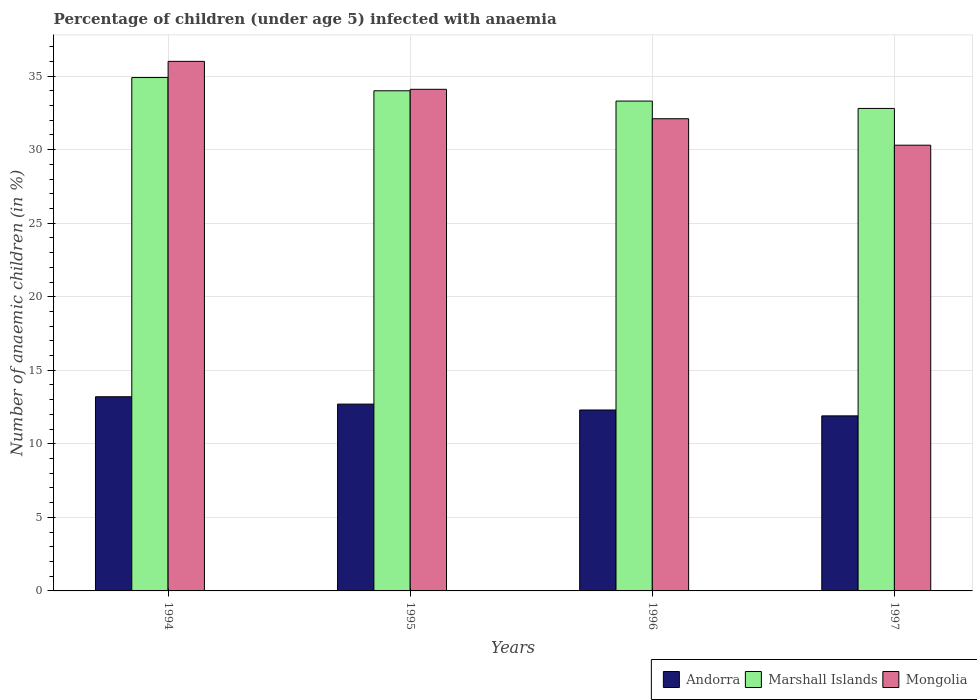How many groups of bars are there?
Provide a short and direct response. 4. Are the number of bars per tick equal to the number of legend labels?
Your answer should be compact. Yes. Are the number of bars on each tick of the X-axis equal?
Your response must be concise. Yes. What is the label of the 2nd group of bars from the left?
Your answer should be compact. 1995. Across all years, what is the maximum percentage of children infected with anaemia in in Andorra?
Give a very brief answer. 13.2. Across all years, what is the minimum percentage of children infected with anaemia in in Mongolia?
Make the answer very short. 30.3. In which year was the percentage of children infected with anaemia in in Marshall Islands maximum?
Provide a short and direct response. 1994. What is the total percentage of children infected with anaemia in in Andorra in the graph?
Keep it short and to the point. 50.1. What is the difference between the percentage of children infected with anaemia in in Marshall Islands in 1995 and that in 1996?
Provide a short and direct response. 0.7. What is the difference between the percentage of children infected with anaemia in in Andorra in 1997 and the percentage of children infected with anaemia in in Marshall Islands in 1994?
Keep it short and to the point. -23. What is the average percentage of children infected with anaemia in in Mongolia per year?
Provide a short and direct response. 33.12. In the year 1995, what is the difference between the percentage of children infected with anaemia in in Mongolia and percentage of children infected with anaemia in in Andorra?
Your response must be concise. 21.4. In how many years, is the percentage of children infected with anaemia in in Mongolia greater than 5 %?
Offer a very short reply. 4. What is the ratio of the percentage of children infected with anaemia in in Marshall Islands in 1995 to that in 1996?
Your response must be concise. 1.02. Is the percentage of children infected with anaemia in in Marshall Islands in 1995 less than that in 1996?
Keep it short and to the point. No. Is the difference between the percentage of children infected with anaemia in in Mongolia in 1994 and 1995 greater than the difference between the percentage of children infected with anaemia in in Andorra in 1994 and 1995?
Give a very brief answer. Yes. What is the difference between the highest and the second highest percentage of children infected with anaemia in in Mongolia?
Your answer should be compact. 1.9. What is the difference between the highest and the lowest percentage of children infected with anaemia in in Mongolia?
Provide a succinct answer. 5.7. In how many years, is the percentage of children infected with anaemia in in Mongolia greater than the average percentage of children infected with anaemia in in Mongolia taken over all years?
Offer a terse response. 2. Is the sum of the percentage of children infected with anaemia in in Andorra in 1994 and 1997 greater than the maximum percentage of children infected with anaemia in in Mongolia across all years?
Offer a very short reply. No. What does the 1st bar from the left in 1995 represents?
Give a very brief answer. Andorra. What does the 2nd bar from the right in 1996 represents?
Provide a short and direct response. Marshall Islands. Are all the bars in the graph horizontal?
Your response must be concise. No. What is the difference between two consecutive major ticks on the Y-axis?
Your answer should be very brief. 5. Does the graph contain any zero values?
Your response must be concise. No. Where does the legend appear in the graph?
Keep it short and to the point. Bottom right. How many legend labels are there?
Your response must be concise. 3. How are the legend labels stacked?
Your response must be concise. Horizontal. What is the title of the graph?
Ensure brevity in your answer.  Percentage of children (under age 5) infected with anaemia. What is the label or title of the X-axis?
Your response must be concise. Years. What is the label or title of the Y-axis?
Your answer should be compact. Number of anaemic children (in %). What is the Number of anaemic children (in %) in Andorra in 1994?
Keep it short and to the point. 13.2. What is the Number of anaemic children (in %) of Marshall Islands in 1994?
Make the answer very short. 34.9. What is the Number of anaemic children (in %) in Mongolia in 1995?
Keep it short and to the point. 34.1. What is the Number of anaemic children (in %) in Marshall Islands in 1996?
Offer a very short reply. 33.3. What is the Number of anaemic children (in %) of Mongolia in 1996?
Provide a succinct answer. 32.1. What is the Number of anaemic children (in %) of Marshall Islands in 1997?
Offer a terse response. 32.8. What is the Number of anaemic children (in %) of Mongolia in 1997?
Ensure brevity in your answer.  30.3. Across all years, what is the maximum Number of anaemic children (in %) of Andorra?
Give a very brief answer. 13.2. Across all years, what is the maximum Number of anaemic children (in %) in Marshall Islands?
Your answer should be very brief. 34.9. Across all years, what is the maximum Number of anaemic children (in %) in Mongolia?
Keep it short and to the point. 36. Across all years, what is the minimum Number of anaemic children (in %) of Andorra?
Keep it short and to the point. 11.9. Across all years, what is the minimum Number of anaemic children (in %) of Marshall Islands?
Provide a succinct answer. 32.8. Across all years, what is the minimum Number of anaemic children (in %) in Mongolia?
Make the answer very short. 30.3. What is the total Number of anaemic children (in %) of Andorra in the graph?
Make the answer very short. 50.1. What is the total Number of anaemic children (in %) of Marshall Islands in the graph?
Provide a succinct answer. 135. What is the total Number of anaemic children (in %) in Mongolia in the graph?
Offer a terse response. 132.5. What is the difference between the Number of anaemic children (in %) of Mongolia in 1994 and that in 1995?
Keep it short and to the point. 1.9. What is the difference between the Number of anaemic children (in %) in Andorra in 1994 and that in 1996?
Provide a succinct answer. 0.9. What is the difference between the Number of anaemic children (in %) in Mongolia in 1994 and that in 1996?
Your answer should be very brief. 3.9. What is the difference between the Number of anaemic children (in %) in Andorra in 1994 and that in 1997?
Offer a terse response. 1.3. What is the difference between the Number of anaemic children (in %) of Marshall Islands in 1994 and that in 1997?
Provide a succinct answer. 2.1. What is the difference between the Number of anaemic children (in %) in Mongolia in 1994 and that in 1997?
Ensure brevity in your answer.  5.7. What is the difference between the Number of anaemic children (in %) in Andorra in 1995 and that in 1996?
Offer a very short reply. 0.4. What is the difference between the Number of anaemic children (in %) of Andorra in 1995 and that in 1997?
Provide a short and direct response. 0.8. What is the difference between the Number of anaemic children (in %) in Marshall Islands in 1995 and that in 1997?
Provide a succinct answer. 1.2. What is the difference between the Number of anaemic children (in %) in Andorra in 1994 and the Number of anaemic children (in %) in Marshall Islands in 1995?
Your answer should be very brief. -20.8. What is the difference between the Number of anaemic children (in %) of Andorra in 1994 and the Number of anaemic children (in %) of Mongolia in 1995?
Offer a very short reply. -20.9. What is the difference between the Number of anaemic children (in %) in Andorra in 1994 and the Number of anaemic children (in %) in Marshall Islands in 1996?
Provide a short and direct response. -20.1. What is the difference between the Number of anaemic children (in %) of Andorra in 1994 and the Number of anaemic children (in %) of Mongolia in 1996?
Offer a very short reply. -18.9. What is the difference between the Number of anaemic children (in %) of Marshall Islands in 1994 and the Number of anaemic children (in %) of Mongolia in 1996?
Offer a very short reply. 2.8. What is the difference between the Number of anaemic children (in %) of Andorra in 1994 and the Number of anaemic children (in %) of Marshall Islands in 1997?
Offer a terse response. -19.6. What is the difference between the Number of anaemic children (in %) of Andorra in 1994 and the Number of anaemic children (in %) of Mongolia in 1997?
Provide a succinct answer. -17.1. What is the difference between the Number of anaemic children (in %) in Andorra in 1995 and the Number of anaemic children (in %) in Marshall Islands in 1996?
Provide a succinct answer. -20.6. What is the difference between the Number of anaemic children (in %) of Andorra in 1995 and the Number of anaemic children (in %) of Mongolia in 1996?
Keep it short and to the point. -19.4. What is the difference between the Number of anaemic children (in %) in Andorra in 1995 and the Number of anaemic children (in %) in Marshall Islands in 1997?
Ensure brevity in your answer.  -20.1. What is the difference between the Number of anaemic children (in %) of Andorra in 1995 and the Number of anaemic children (in %) of Mongolia in 1997?
Provide a succinct answer. -17.6. What is the difference between the Number of anaemic children (in %) of Andorra in 1996 and the Number of anaemic children (in %) of Marshall Islands in 1997?
Your answer should be very brief. -20.5. What is the difference between the Number of anaemic children (in %) of Andorra in 1996 and the Number of anaemic children (in %) of Mongolia in 1997?
Provide a short and direct response. -18. What is the average Number of anaemic children (in %) in Andorra per year?
Your response must be concise. 12.53. What is the average Number of anaemic children (in %) in Marshall Islands per year?
Your answer should be very brief. 33.75. What is the average Number of anaemic children (in %) in Mongolia per year?
Provide a short and direct response. 33.12. In the year 1994, what is the difference between the Number of anaemic children (in %) of Andorra and Number of anaemic children (in %) of Marshall Islands?
Provide a short and direct response. -21.7. In the year 1994, what is the difference between the Number of anaemic children (in %) in Andorra and Number of anaemic children (in %) in Mongolia?
Offer a very short reply. -22.8. In the year 1995, what is the difference between the Number of anaemic children (in %) in Andorra and Number of anaemic children (in %) in Marshall Islands?
Your answer should be compact. -21.3. In the year 1995, what is the difference between the Number of anaemic children (in %) of Andorra and Number of anaemic children (in %) of Mongolia?
Provide a succinct answer. -21.4. In the year 1996, what is the difference between the Number of anaemic children (in %) in Andorra and Number of anaemic children (in %) in Mongolia?
Offer a very short reply. -19.8. In the year 1997, what is the difference between the Number of anaemic children (in %) in Andorra and Number of anaemic children (in %) in Marshall Islands?
Provide a succinct answer. -20.9. In the year 1997, what is the difference between the Number of anaemic children (in %) of Andorra and Number of anaemic children (in %) of Mongolia?
Your answer should be very brief. -18.4. In the year 1997, what is the difference between the Number of anaemic children (in %) in Marshall Islands and Number of anaemic children (in %) in Mongolia?
Offer a terse response. 2.5. What is the ratio of the Number of anaemic children (in %) of Andorra in 1994 to that in 1995?
Offer a very short reply. 1.04. What is the ratio of the Number of anaemic children (in %) in Marshall Islands in 1994 to that in 1995?
Offer a very short reply. 1.03. What is the ratio of the Number of anaemic children (in %) of Mongolia in 1994 to that in 1995?
Your answer should be compact. 1.06. What is the ratio of the Number of anaemic children (in %) in Andorra in 1994 to that in 1996?
Ensure brevity in your answer.  1.07. What is the ratio of the Number of anaemic children (in %) of Marshall Islands in 1994 to that in 1996?
Give a very brief answer. 1.05. What is the ratio of the Number of anaemic children (in %) in Mongolia in 1994 to that in 1996?
Your answer should be compact. 1.12. What is the ratio of the Number of anaemic children (in %) of Andorra in 1994 to that in 1997?
Make the answer very short. 1.11. What is the ratio of the Number of anaemic children (in %) in Marshall Islands in 1994 to that in 1997?
Give a very brief answer. 1.06. What is the ratio of the Number of anaemic children (in %) in Mongolia in 1994 to that in 1997?
Ensure brevity in your answer.  1.19. What is the ratio of the Number of anaemic children (in %) of Andorra in 1995 to that in 1996?
Your answer should be compact. 1.03. What is the ratio of the Number of anaemic children (in %) of Marshall Islands in 1995 to that in 1996?
Provide a succinct answer. 1.02. What is the ratio of the Number of anaemic children (in %) of Mongolia in 1995 to that in 1996?
Offer a terse response. 1.06. What is the ratio of the Number of anaemic children (in %) of Andorra in 1995 to that in 1997?
Your answer should be compact. 1.07. What is the ratio of the Number of anaemic children (in %) in Marshall Islands in 1995 to that in 1997?
Your answer should be compact. 1.04. What is the ratio of the Number of anaemic children (in %) in Mongolia in 1995 to that in 1997?
Offer a terse response. 1.13. What is the ratio of the Number of anaemic children (in %) of Andorra in 1996 to that in 1997?
Offer a terse response. 1.03. What is the ratio of the Number of anaemic children (in %) in Marshall Islands in 1996 to that in 1997?
Provide a short and direct response. 1.02. What is the ratio of the Number of anaemic children (in %) of Mongolia in 1996 to that in 1997?
Give a very brief answer. 1.06. What is the difference between the highest and the second highest Number of anaemic children (in %) of Marshall Islands?
Provide a succinct answer. 0.9. What is the difference between the highest and the second highest Number of anaemic children (in %) of Mongolia?
Offer a terse response. 1.9. What is the difference between the highest and the lowest Number of anaemic children (in %) of Mongolia?
Offer a terse response. 5.7. 